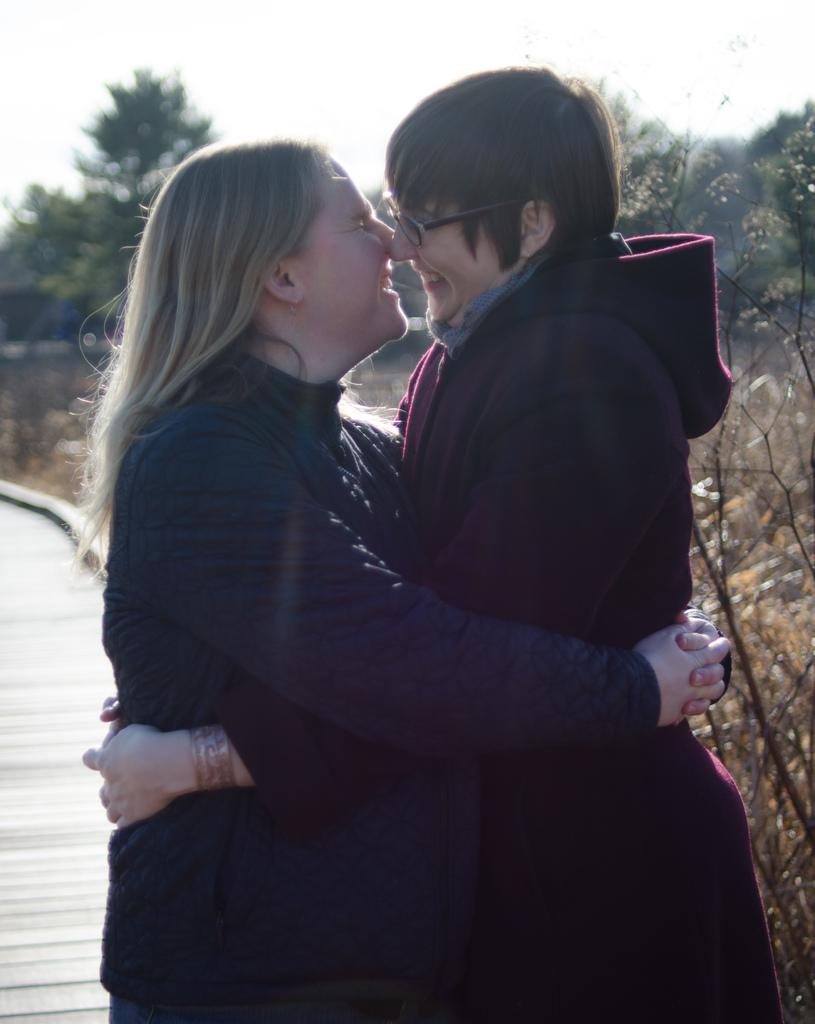How many people are in the image? There are two people in the image. What are the two people doing in the image? The two people are hugging each other. What can be seen in the background of the image? There are trees and the sky visible in the background of the image. What type of operation is being performed on the gold in the image? There is no operation or gold present in the image; it features two people hugging each other with trees and the sky in the background. 